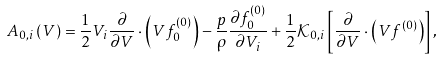Convert formula to latex. <formula><loc_0><loc_0><loc_500><loc_500>A _ { 0 , i } \left ( V \right ) = \frac { 1 } { 2 } V _ { i } \frac { \partial } { \partial { V } } \cdot \left ( V f _ { 0 } ^ { ( 0 ) } \right ) - \frac { p } { \rho } \frac { \partial f _ { 0 } ^ { ( 0 ) } } { \partial V _ { i } } + \frac { 1 } { 2 } \mathcal { K } _ { 0 , i } \left [ \frac { \partial } { \partial { V } } \cdot \left ( V f ^ { ( 0 ) } \right ) \right ] ,</formula> 